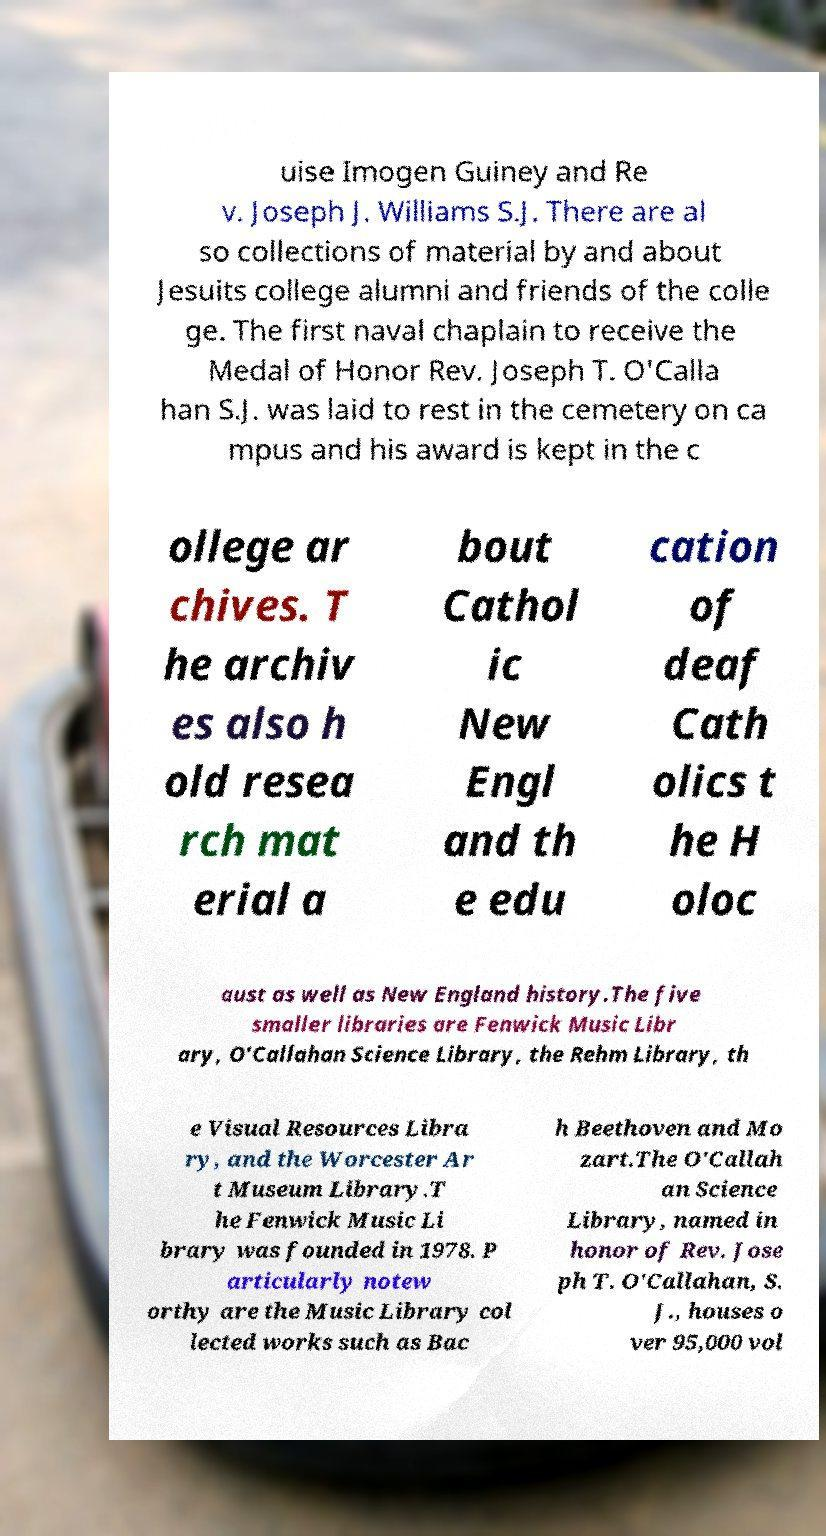For documentation purposes, I need the text within this image transcribed. Could you provide that? uise Imogen Guiney and Re v. Joseph J. Williams S.J. There are al so collections of material by and about Jesuits college alumni and friends of the colle ge. The first naval chaplain to receive the Medal of Honor Rev. Joseph T. O'Calla han S.J. was laid to rest in the cemetery on ca mpus and his award is kept in the c ollege ar chives. T he archiv es also h old resea rch mat erial a bout Cathol ic New Engl and th e edu cation of deaf Cath olics t he H oloc aust as well as New England history.The five smaller libraries are Fenwick Music Libr ary, O'Callahan Science Library, the Rehm Library, th e Visual Resources Libra ry, and the Worcester Ar t Museum Library.T he Fenwick Music Li brary was founded in 1978. P articularly notew orthy are the Music Library col lected works such as Bac h Beethoven and Mo zart.The O'Callah an Science Library, named in honor of Rev. Jose ph T. O'Callahan, S. J., houses o ver 95,000 vol 